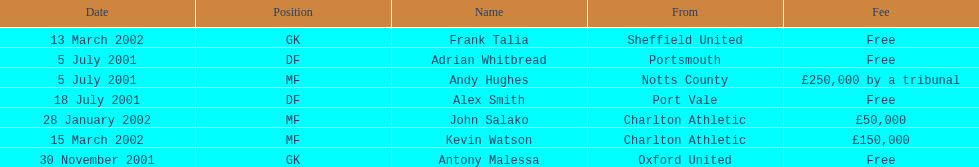What was the transfer fee to transfer kevin watson? £150,000. Can you give me this table as a dict? {'header': ['Date', 'Position', 'Name', 'From', 'Fee'], 'rows': [['13 March 2002', 'GK', 'Frank Talia', 'Sheffield United', 'Free'], ['5 July 2001', 'DF', 'Adrian Whitbread', 'Portsmouth', 'Free'], ['5 July 2001', 'MF', 'Andy Hughes', 'Notts County', '£250,000 by a tribunal'], ['18 July 2001', 'DF', 'Alex Smith', 'Port Vale', 'Free'], ['28 January 2002', 'MF', 'John Salako', 'Charlton Athletic', '£50,000'], ['15 March 2002', 'MF', 'Kevin Watson', 'Charlton Athletic', '£150,000'], ['30 November 2001', 'GK', 'Antony Malessa', 'Oxford United', 'Free']]} 